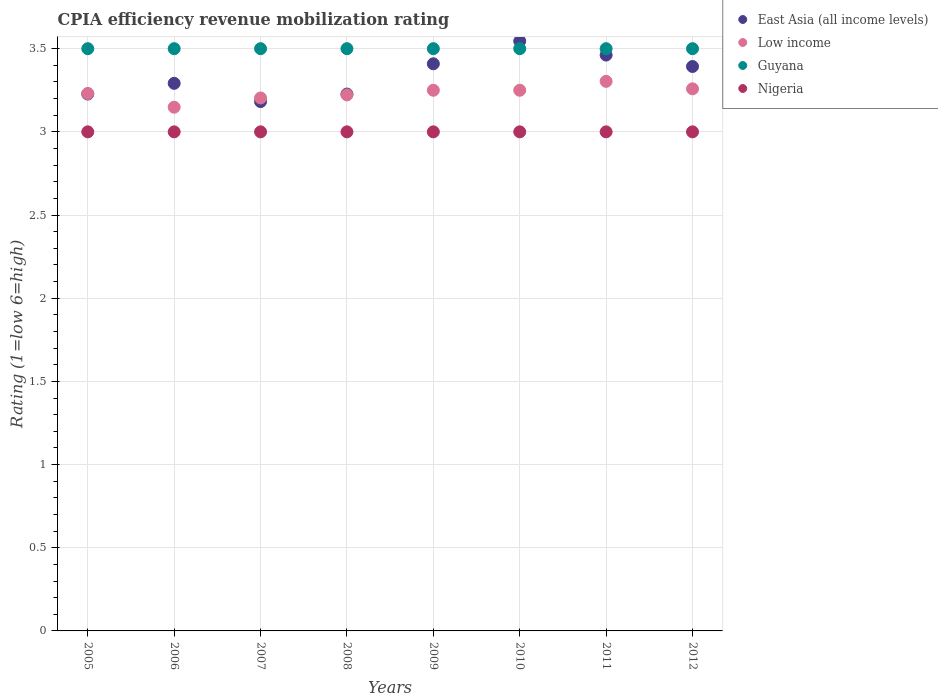Is the number of dotlines equal to the number of legend labels?
Ensure brevity in your answer.  Yes. What is the CPIA rating in East Asia (all income levels) in 2008?
Your answer should be very brief. 3.23. Across all years, what is the minimum CPIA rating in Nigeria?
Provide a short and direct response. 3. In which year was the CPIA rating in Nigeria maximum?
Offer a terse response. 2005. In which year was the CPIA rating in Low income minimum?
Provide a succinct answer. 2006. What is the total CPIA rating in Low income in the graph?
Provide a short and direct response. 25.87. In how many years, is the CPIA rating in Nigeria greater than 1.9?
Offer a terse response. 8. What is the ratio of the CPIA rating in East Asia (all income levels) in 2006 to that in 2007?
Offer a terse response. 1.03. What is the difference between the highest and the second highest CPIA rating in Guyana?
Ensure brevity in your answer.  0. What is the difference between the highest and the lowest CPIA rating in Nigeria?
Keep it short and to the point. 0. Is the sum of the CPIA rating in Guyana in 2008 and 2012 greater than the maximum CPIA rating in Low income across all years?
Make the answer very short. Yes. Does the CPIA rating in Low income monotonically increase over the years?
Your answer should be compact. No. What is the difference between two consecutive major ticks on the Y-axis?
Offer a terse response. 0.5. Where does the legend appear in the graph?
Keep it short and to the point. Top right. How are the legend labels stacked?
Your answer should be compact. Vertical. What is the title of the graph?
Your answer should be compact. CPIA efficiency revenue mobilization rating. What is the label or title of the X-axis?
Provide a succinct answer. Years. What is the Rating (1=low 6=high) of East Asia (all income levels) in 2005?
Your answer should be compact. 3.23. What is the Rating (1=low 6=high) in Low income in 2005?
Your answer should be very brief. 3.23. What is the Rating (1=low 6=high) in Guyana in 2005?
Offer a very short reply. 3.5. What is the Rating (1=low 6=high) of Nigeria in 2005?
Offer a very short reply. 3. What is the Rating (1=low 6=high) in East Asia (all income levels) in 2006?
Provide a short and direct response. 3.29. What is the Rating (1=low 6=high) in Low income in 2006?
Provide a succinct answer. 3.15. What is the Rating (1=low 6=high) in Nigeria in 2006?
Provide a succinct answer. 3. What is the Rating (1=low 6=high) in East Asia (all income levels) in 2007?
Provide a succinct answer. 3.18. What is the Rating (1=low 6=high) of Low income in 2007?
Ensure brevity in your answer.  3.2. What is the Rating (1=low 6=high) of Nigeria in 2007?
Provide a short and direct response. 3. What is the Rating (1=low 6=high) in East Asia (all income levels) in 2008?
Your answer should be compact. 3.23. What is the Rating (1=low 6=high) in Low income in 2008?
Your response must be concise. 3.22. What is the Rating (1=low 6=high) of Guyana in 2008?
Give a very brief answer. 3.5. What is the Rating (1=low 6=high) of East Asia (all income levels) in 2009?
Make the answer very short. 3.41. What is the Rating (1=low 6=high) of Guyana in 2009?
Your answer should be very brief. 3.5. What is the Rating (1=low 6=high) of East Asia (all income levels) in 2010?
Keep it short and to the point. 3.55. What is the Rating (1=low 6=high) in Low income in 2010?
Provide a short and direct response. 3.25. What is the Rating (1=low 6=high) in Guyana in 2010?
Your answer should be very brief. 3.5. What is the Rating (1=low 6=high) of Nigeria in 2010?
Make the answer very short. 3. What is the Rating (1=low 6=high) of East Asia (all income levels) in 2011?
Your answer should be compact. 3.46. What is the Rating (1=low 6=high) of Low income in 2011?
Offer a very short reply. 3.3. What is the Rating (1=low 6=high) in East Asia (all income levels) in 2012?
Your answer should be compact. 3.39. What is the Rating (1=low 6=high) of Low income in 2012?
Your answer should be compact. 3.26. Across all years, what is the maximum Rating (1=low 6=high) of East Asia (all income levels)?
Offer a very short reply. 3.55. Across all years, what is the maximum Rating (1=low 6=high) of Low income?
Your response must be concise. 3.3. Across all years, what is the maximum Rating (1=low 6=high) in Guyana?
Offer a terse response. 3.5. Across all years, what is the minimum Rating (1=low 6=high) in East Asia (all income levels)?
Offer a very short reply. 3.18. Across all years, what is the minimum Rating (1=low 6=high) of Low income?
Your answer should be very brief. 3.15. Across all years, what is the minimum Rating (1=low 6=high) of Guyana?
Provide a short and direct response. 3.5. Across all years, what is the minimum Rating (1=low 6=high) of Nigeria?
Provide a succinct answer. 3. What is the total Rating (1=low 6=high) in East Asia (all income levels) in the graph?
Ensure brevity in your answer.  26.74. What is the total Rating (1=low 6=high) of Low income in the graph?
Your answer should be very brief. 25.87. What is the total Rating (1=low 6=high) in Guyana in the graph?
Provide a succinct answer. 28. What is the difference between the Rating (1=low 6=high) in East Asia (all income levels) in 2005 and that in 2006?
Offer a terse response. -0.06. What is the difference between the Rating (1=low 6=high) in Low income in 2005 and that in 2006?
Provide a short and direct response. 0.08. What is the difference between the Rating (1=low 6=high) in Guyana in 2005 and that in 2006?
Provide a short and direct response. 0. What is the difference between the Rating (1=low 6=high) of East Asia (all income levels) in 2005 and that in 2007?
Offer a terse response. 0.05. What is the difference between the Rating (1=low 6=high) in Low income in 2005 and that in 2007?
Your answer should be compact. 0.03. What is the difference between the Rating (1=low 6=high) of Guyana in 2005 and that in 2007?
Make the answer very short. 0. What is the difference between the Rating (1=low 6=high) of East Asia (all income levels) in 2005 and that in 2008?
Offer a very short reply. 0. What is the difference between the Rating (1=low 6=high) of Low income in 2005 and that in 2008?
Offer a terse response. 0.01. What is the difference between the Rating (1=low 6=high) in Nigeria in 2005 and that in 2008?
Provide a short and direct response. 0. What is the difference between the Rating (1=low 6=high) in East Asia (all income levels) in 2005 and that in 2009?
Your answer should be very brief. -0.18. What is the difference between the Rating (1=low 6=high) of Low income in 2005 and that in 2009?
Ensure brevity in your answer.  -0.02. What is the difference between the Rating (1=low 6=high) of Guyana in 2005 and that in 2009?
Keep it short and to the point. 0. What is the difference between the Rating (1=low 6=high) in Nigeria in 2005 and that in 2009?
Make the answer very short. 0. What is the difference between the Rating (1=low 6=high) in East Asia (all income levels) in 2005 and that in 2010?
Your answer should be compact. -0.32. What is the difference between the Rating (1=low 6=high) in Low income in 2005 and that in 2010?
Your response must be concise. -0.02. What is the difference between the Rating (1=low 6=high) in East Asia (all income levels) in 2005 and that in 2011?
Offer a terse response. -0.23. What is the difference between the Rating (1=low 6=high) in Low income in 2005 and that in 2011?
Your response must be concise. -0.07. What is the difference between the Rating (1=low 6=high) in East Asia (all income levels) in 2005 and that in 2012?
Your response must be concise. -0.17. What is the difference between the Rating (1=low 6=high) in Low income in 2005 and that in 2012?
Your response must be concise. -0.03. What is the difference between the Rating (1=low 6=high) of Guyana in 2005 and that in 2012?
Make the answer very short. 0. What is the difference between the Rating (1=low 6=high) of East Asia (all income levels) in 2006 and that in 2007?
Provide a succinct answer. 0.11. What is the difference between the Rating (1=low 6=high) of Low income in 2006 and that in 2007?
Your response must be concise. -0.06. What is the difference between the Rating (1=low 6=high) of East Asia (all income levels) in 2006 and that in 2008?
Make the answer very short. 0.06. What is the difference between the Rating (1=low 6=high) in Low income in 2006 and that in 2008?
Your answer should be compact. -0.07. What is the difference between the Rating (1=low 6=high) of Guyana in 2006 and that in 2008?
Provide a short and direct response. 0. What is the difference between the Rating (1=low 6=high) in Nigeria in 2006 and that in 2008?
Provide a short and direct response. 0. What is the difference between the Rating (1=low 6=high) of East Asia (all income levels) in 2006 and that in 2009?
Provide a short and direct response. -0.12. What is the difference between the Rating (1=low 6=high) of Low income in 2006 and that in 2009?
Offer a very short reply. -0.1. What is the difference between the Rating (1=low 6=high) in East Asia (all income levels) in 2006 and that in 2010?
Your answer should be compact. -0.25. What is the difference between the Rating (1=low 6=high) of Low income in 2006 and that in 2010?
Your answer should be compact. -0.1. What is the difference between the Rating (1=low 6=high) in Guyana in 2006 and that in 2010?
Offer a very short reply. 0. What is the difference between the Rating (1=low 6=high) in East Asia (all income levels) in 2006 and that in 2011?
Ensure brevity in your answer.  -0.17. What is the difference between the Rating (1=low 6=high) in Low income in 2006 and that in 2011?
Provide a short and direct response. -0.16. What is the difference between the Rating (1=low 6=high) in Guyana in 2006 and that in 2011?
Make the answer very short. 0. What is the difference between the Rating (1=low 6=high) of East Asia (all income levels) in 2006 and that in 2012?
Your answer should be very brief. -0.1. What is the difference between the Rating (1=low 6=high) in Low income in 2006 and that in 2012?
Offer a terse response. -0.11. What is the difference between the Rating (1=low 6=high) in Nigeria in 2006 and that in 2012?
Provide a succinct answer. 0. What is the difference between the Rating (1=low 6=high) in East Asia (all income levels) in 2007 and that in 2008?
Ensure brevity in your answer.  -0.05. What is the difference between the Rating (1=low 6=high) of Low income in 2007 and that in 2008?
Your response must be concise. -0.02. What is the difference between the Rating (1=low 6=high) in East Asia (all income levels) in 2007 and that in 2009?
Make the answer very short. -0.23. What is the difference between the Rating (1=low 6=high) of Low income in 2007 and that in 2009?
Ensure brevity in your answer.  -0.05. What is the difference between the Rating (1=low 6=high) in Guyana in 2007 and that in 2009?
Your answer should be very brief. 0. What is the difference between the Rating (1=low 6=high) of Nigeria in 2007 and that in 2009?
Give a very brief answer. 0. What is the difference between the Rating (1=low 6=high) of East Asia (all income levels) in 2007 and that in 2010?
Keep it short and to the point. -0.36. What is the difference between the Rating (1=low 6=high) in Low income in 2007 and that in 2010?
Keep it short and to the point. -0.05. What is the difference between the Rating (1=low 6=high) in Nigeria in 2007 and that in 2010?
Provide a short and direct response. 0. What is the difference between the Rating (1=low 6=high) of East Asia (all income levels) in 2007 and that in 2011?
Your answer should be compact. -0.28. What is the difference between the Rating (1=low 6=high) of Low income in 2007 and that in 2011?
Offer a terse response. -0.1. What is the difference between the Rating (1=low 6=high) in Guyana in 2007 and that in 2011?
Keep it short and to the point. 0. What is the difference between the Rating (1=low 6=high) of East Asia (all income levels) in 2007 and that in 2012?
Keep it short and to the point. -0.21. What is the difference between the Rating (1=low 6=high) in Low income in 2007 and that in 2012?
Offer a very short reply. -0.05. What is the difference between the Rating (1=low 6=high) of Guyana in 2007 and that in 2012?
Offer a very short reply. 0. What is the difference between the Rating (1=low 6=high) of Nigeria in 2007 and that in 2012?
Offer a terse response. 0. What is the difference between the Rating (1=low 6=high) of East Asia (all income levels) in 2008 and that in 2009?
Provide a succinct answer. -0.18. What is the difference between the Rating (1=low 6=high) of Low income in 2008 and that in 2009?
Your answer should be very brief. -0.03. What is the difference between the Rating (1=low 6=high) of Guyana in 2008 and that in 2009?
Keep it short and to the point. 0. What is the difference between the Rating (1=low 6=high) in East Asia (all income levels) in 2008 and that in 2010?
Give a very brief answer. -0.32. What is the difference between the Rating (1=low 6=high) of Low income in 2008 and that in 2010?
Keep it short and to the point. -0.03. What is the difference between the Rating (1=low 6=high) of Guyana in 2008 and that in 2010?
Offer a terse response. 0. What is the difference between the Rating (1=low 6=high) in Nigeria in 2008 and that in 2010?
Your response must be concise. 0. What is the difference between the Rating (1=low 6=high) of East Asia (all income levels) in 2008 and that in 2011?
Offer a terse response. -0.23. What is the difference between the Rating (1=low 6=high) of Low income in 2008 and that in 2011?
Your answer should be very brief. -0.08. What is the difference between the Rating (1=low 6=high) in East Asia (all income levels) in 2008 and that in 2012?
Ensure brevity in your answer.  -0.17. What is the difference between the Rating (1=low 6=high) of Low income in 2008 and that in 2012?
Offer a very short reply. -0.04. What is the difference between the Rating (1=low 6=high) of Nigeria in 2008 and that in 2012?
Make the answer very short. 0. What is the difference between the Rating (1=low 6=high) in East Asia (all income levels) in 2009 and that in 2010?
Keep it short and to the point. -0.14. What is the difference between the Rating (1=low 6=high) in Nigeria in 2009 and that in 2010?
Keep it short and to the point. 0. What is the difference between the Rating (1=low 6=high) of East Asia (all income levels) in 2009 and that in 2011?
Keep it short and to the point. -0.05. What is the difference between the Rating (1=low 6=high) of Low income in 2009 and that in 2011?
Keep it short and to the point. -0.05. What is the difference between the Rating (1=low 6=high) in Nigeria in 2009 and that in 2011?
Offer a very short reply. 0. What is the difference between the Rating (1=low 6=high) of East Asia (all income levels) in 2009 and that in 2012?
Your answer should be compact. 0.02. What is the difference between the Rating (1=low 6=high) in Low income in 2009 and that in 2012?
Make the answer very short. -0.01. What is the difference between the Rating (1=low 6=high) of Nigeria in 2009 and that in 2012?
Offer a terse response. 0. What is the difference between the Rating (1=low 6=high) in East Asia (all income levels) in 2010 and that in 2011?
Your answer should be very brief. 0.08. What is the difference between the Rating (1=low 6=high) of Low income in 2010 and that in 2011?
Make the answer very short. -0.05. What is the difference between the Rating (1=low 6=high) of Nigeria in 2010 and that in 2011?
Provide a succinct answer. 0. What is the difference between the Rating (1=low 6=high) in East Asia (all income levels) in 2010 and that in 2012?
Offer a very short reply. 0.15. What is the difference between the Rating (1=low 6=high) in Low income in 2010 and that in 2012?
Give a very brief answer. -0.01. What is the difference between the Rating (1=low 6=high) of Guyana in 2010 and that in 2012?
Offer a very short reply. 0. What is the difference between the Rating (1=low 6=high) of East Asia (all income levels) in 2011 and that in 2012?
Your answer should be very brief. 0.07. What is the difference between the Rating (1=low 6=high) in Low income in 2011 and that in 2012?
Provide a succinct answer. 0.04. What is the difference between the Rating (1=low 6=high) in Guyana in 2011 and that in 2012?
Keep it short and to the point. 0. What is the difference between the Rating (1=low 6=high) of Nigeria in 2011 and that in 2012?
Provide a succinct answer. 0. What is the difference between the Rating (1=low 6=high) of East Asia (all income levels) in 2005 and the Rating (1=low 6=high) of Low income in 2006?
Provide a short and direct response. 0.08. What is the difference between the Rating (1=low 6=high) in East Asia (all income levels) in 2005 and the Rating (1=low 6=high) in Guyana in 2006?
Offer a terse response. -0.27. What is the difference between the Rating (1=low 6=high) in East Asia (all income levels) in 2005 and the Rating (1=low 6=high) in Nigeria in 2006?
Offer a very short reply. 0.23. What is the difference between the Rating (1=low 6=high) of Low income in 2005 and the Rating (1=low 6=high) of Guyana in 2006?
Ensure brevity in your answer.  -0.27. What is the difference between the Rating (1=low 6=high) of Low income in 2005 and the Rating (1=low 6=high) of Nigeria in 2006?
Your answer should be very brief. 0.23. What is the difference between the Rating (1=low 6=high) in Guyana in 2005 and the Rating (1=low 6=high) in Nigeria in 2006?
Keep it short and to the point. 0.5. What is the difference between the Rating (1=low 6=high) of East Asia (all income levels) in 2005 and the Rating (1=low 6=high) of Low income in 2007?
Your answer should be very brief. 0.02. What is the difference between the Rating (1=low 6=high) of East Asia (all income levels) in 2005 and the Rating (1=low 6=high) of Guyana in 2007?
Keep it short and to the point. -0.27. What is the difference between the Rating (1=low 6=high) in East Asia (all income levels) in 2005 and the Rating (1=low 6=high) in Nigeria in 2007?
Provide a short and direct response. 0.23. What is the difference between the Rating (1=low 6=high) in Low income in 2005 and the Rating (1=low 6=high) in Guyana in 2007?
Offer a terse response. -0.27. What is the difference between the Rating (1=low 6=high) of Low income in 2005 and the Rating (1=low 6=high) of Nigeria in 2007?
Offer a terse response. 0.23. What is the difference between the Rating (1=low 6=high) in Guyana in 2005 and the Rating (1=low 6=high) in Nigeria in 2007?
Offer a very short reply. 0.5. What is the difference between the Rating (1=low 6=high) of East Asia (all income levels) in 2005 and the Rating (1=low 6=high) of Low income in 2008?
Make the answer very short. 0.01. What is the difference between the Rating (1=low 6=high) in East Asia (all income levels) in 2005 and the Rating (1=low 6=high) in Guyana in 2008?
Your response must be concise. -0.27. What is the difference between the Rating (1=low 6=high) of East Asia (all income levels) in 2005 and the Rating (1=low 6=high) of Nigeria in 2008?
Your response must be concise. 0.23. What is the difference between the Rating (1=low 6=high) in Low income in 2005 and the Rating (1=low 6=high) in Guyana in 2008?
Provide a succinct answer. -0.27. What is the difference between the Rating (1=low 6=high) of Low income in 2005 and the Rating (1=low 6=high) of Nigeria in 2008?
Your answer should be very brief. 0.23. What is the difference between the Rating (1=low 6=high) of East Asia (all income levels) in 2005 and the Rating (1=low 6=high) of Low income in 2009?
Offer a very short reply. -0.02. What is the difference between the Rating (1=low 6=high) in East Asia (all income levels) in 2005 and the Rating (1=low 6=high) in Guyana in 2009?
Ensure brevity in your answer.  -0.27. What is the difference between the Rating (1=low 6=high) of East Asia (all income levels) in 2005 and the Rating (1=low 6=high) of Nigeria in 2009?
Your answer should be very brief. 0.23. What is the difference between the Rating (1=low 6=high) of Low income in 2005 and the Rating (1=low 6=high) of Guyana in 2009?
Offer a very short reply. -0.27. What is the difference between the Rating (1=low 6=high) of Low income in 2005 and the Rating (1=low 6=high) of Nigeria in 2009?
Keep it short and to the point. 0.23. What is the difference between the Rating (1=low 6=high) of East Asia (all income levels) in 2005 and the Rating (1=low 6=high) of Low income in 2010?
Offer a terse response. -0.02. What is the difference between the Rating (1=low 6=high) of East Asia (all income levels) in 2005 and the Rating (1=low 6=high) of Guyana in 2010?
Give a very brief answer. -0.27. What is the difference between the Rating (1=low 6=high) of East Asia (all income levels) in 2005 and the Rating (1=low 6=high) of Nigeria in 2010?
Provide a succinct answer. 0.23. What is the difference between the Rating (1=low 6=high) of Low income in 2005 and the Rating (1=low 6=high) of Guyana in 2010?
Keep it short and to the point. -0.27. What is the difference between the Rating (1=low 6=high) in Low income in 2005 and the Rating (1=low 6=high) in Nigeria in 2010?
Offer a terse response. 0.23. What is the difference between the Rating (1=low 6=high) of East Asia (all income levels) in 2005 and the Rating (1=low 6=high) of Low income in 2011?
Offer a very short reply. -0.08. What is the difference between the Rating (1=low 6=high) of East Asia (all income levels) in 2005 and the Rating (1=low 6=high) of Guyana in 2011?
Your answer should be very brief. -0.27. What is the difference between the Rating (1=low 6=high) of East Asia (all income levels) in 2005 and the Rating (1=low 6=high) of Nigeria in 2011?
Offer a terse response. 0.23. What is the difference between the Rating (1=low 6=high) of Low income in 2005 and the Rating (1=low 6=high) of Guyana in 2011?
Make the answer very short. -0.27. What is the difference between the Rating (1=low 6=high) in Low income in 2005 and the Rating (1=low 6=high) in Nigeria in 2011?
Make the answer very short. 0.23. What is the difference between the Rating (1=low 6=high) of Guyana in 2005 and the Rating (1=low 6=high) of Nigeria in 2011?
Offer a very short reply. 0.5. What is the difference between the Rating (1=low 6=high) in East Asia (all income levels) in 2005 and the Rating (1=low 6=high) in Low income in 2012?
Provide a short and direct response. -0.03. What is the difference between the Rating (1=low 6=high) of East Asia (all income levels) in 2005 and the Rating (1=low 6=high) of Guyana in 2012?
Make the answer very short. -0.27. What is the difference between the Rating (1=low 6=high) of East Asia (all income levels) in 2005 and the Rating (1=low 6=high) of Nigeria in 2012?
Ensure brevity in your answer.  0.23. What is the difference between the Rating (1=low 6=high) in Low income in 2005 and the Rating (1=low 6=high) in Guyana in 2012?
Ensure brevity in your answer.  -0.27. What is the difference between the Rating (1=low 6=high) in Low income in 2005 and the Rating (1=low 6=high) in Nigeria in 2012?
Provide a succinct answer. 0.23. What is the difference between the Rating (1=low 6=high) in Guyana in 2005 and the Rating (1=low 6=high) in Nigeria in 2012?
Provide a succinct answer. 0.5. What is the difference between the Rating (1=low 6=high) of East Asia (all income levels) in 2006 and the Rating (1=low 6=high) of Low income in 2007?
Provide a short and direct response. 0.09. What is the difference between the Rating (1=low 6=high) in East Asia (all income levels) in 2006 and the Rating (1=low 6=high) in Guyana in 2007?
Offer a very short reply. -0.21. What is the difference between the Rating (1=low 6=high) in East Asia (all income levels) in 2006 and the Rating (1=low 6=high) in Nigeria in 2007?
Offer a terse response. 0.29. What is the difference between the Rating (1=low 6=high) in Low income in 2006 and the Rating (1=low 6=high) in Guyana in 2007?
Keep it short and to the point. -0.35. What is the difference between the Rating (1=low 6=high) in Low income in 2006 and the Rating (1=low 6=high) in Nigeria in 2007?
Your response must be concise. 0.15. What is the difference between the Rating (1=low 6=high) in East Asia (all income levels) in 2006 and the Rating (1=low 6=high) in Low income in 2008?
Provide a succinct answer. 0.07. What is the difference between the Rating (1=low 6=high) in East Asia (all income levels) in 2006 and the Rating (1=low 6=high) in Guyana in 2008?
Keep it short and to the point. -0.21. What is the difference between the Rating (1=low 6=high) of East Asia (all income levels) in 2006 and the Rating (1=low 6=high) of Nigeria in 2008?
Make the answer very short. 0.29. What is the difference between the Rating (1=low 6=high) of Low income in 2006 and the Rating (1=low 6=high) of Guyana in 2008?
Make the answer very short. -0.35. What is the difference between the Rating (1=low 6=high) of Low income in 2006 and the Rating (1=low 6=high) of Nigeria in 2008?
Your answer should be compact. 0.15. What is the difference between the Rating (1=low 6=high) of Guyana in 2006 and the Rating (1=low 6=high) of Nigeria in 2008?
Provide a short and direct response. 0.5. What is the difference between the Rating (1=low 6=high) of East Asia (all income levels) in 2006 and the Rating (1=low 6=high) of Low income in 2009?
Your response must be concise. 0.04. What is the difference between the Rating (1=low 6=high) of East Asia (all income levels) in 2006 and the Rating (1=low 6=high) of Guyana in 2009?
Ensure brevity in your answer.  -0.21. What is the difference between the Rating (1=low 6=high) in East Asia (all income levels) in 2006 and the Rating (1=low 6=high) in Nigeria in 2009?
Your answer should be very brief. 0.29. What is the difference between the Rating (1=low 6=high) in Low income in 2006 and the Rating (1=low 6=high) in Guyana in 2009?
Ensure brevity in your answer.  -0.35. What is the difference between the Rating (1=low 6=high) in Low income in 2006 and the Rating (1=low 6=high) in Nigeria in 2009?
Your answer should be compact. 0.15. What is the difference between the Rating (1=low 6=high) of East Asia (all income levels) in 2006 and the Rating (1=low 6=high) of Low income in 2010?
Offer a terse response. 0.04. What is the difference between the Rating (1=low 6=high) of East Asia (all income levels) in 2006 and the Rating (1=low 6=high) of Guyana in 2010?
Your answer should be compact. -0.21. What is the difference between the Rating (1=low 6=high) of East Asia (all income levels) in 2006 and the Rating (1=low 6=high) of Nigeria in 2010?
Your response must be concise. 0.29. What is the difference between the Rating (1=low 6=high) in Low income in 2006 and the Rating (1=low 6=high) in Guyana in 2010?
Your response must be concise. -0.35. What is the difference between the Rating (1=low 6=high) in Low income in 2006 and the Rating (1=low 6=high) in Nigeria in 2010?
Offer a terse response. 0.15. What is the difference between the Rating (1=low 6=high) of Guyana in 2006 and the Rating (1=low 6=high) of Nigeria in 2010?
Offer a very short reply. 0.5. What is the difference between the Rating (1=low 6=high) in East Asia (all income levels) in 2006 and the Rating (1=low 6=high) in Low income in 2011?
Keep it short and to the point. -0.01. What is the difference between the Rating (1=low 6=high) in East Asia (all income levels) in 2006 and the Rating (1=low 6=high) in Guyana in 2011?
Offer a very short reply. -0.21. What is the difference between the Rating (1=low 6=high) of East Asia (all income levels) in 2006 and the Rating (1=low 6=high) of Nigeria in 2011?
Your answer should be very brief. 0.29. What is the difference between the Rating (1=low 6=high) of Low income in 2006 and the Rating (1=low 6=high) of Guyana in 2011?
Give a very brief answer. -0.35. What is the difference between the Rating (1=low 6=high) in Low income in 2006 and the Rating (1=low 6=high) in Nigeria in 2011?
Offer a terse response. 0.15. What is the difference between the Rating (1=low 6=high) in East Asia (all income levels) in 2006 and the Rating (1=low 6=high) in Low income in 2012?
Offer a terse response. 0.03. What is the difference between the Rating (1=low 6=high) in East Asia (all income levels) in 2006 and the Rating (1=low 6=high) in Guyana in 2012?
Your response must be concise. -0.21. What is the difference between the Rating (1=low 6=high) of East Asia (all income levels) in 2006 and the Rating (1=low 6=high) of Nigeria in 2012?
Provide a succinct answer. 0.29. What is the difference between the Rating (1=low 6=high) in Low income in 2006 and the Rating (1=low 6=high) in Guyana in 2012?
Your response must be concise. -0.35. What is the difference between the Rating (1=low 6=high) in Low income in 2006 and the Rating (1=low 6=high) in Nigeria in 2012?
Ensure brevity in your answer.  0.15. What is the difference between the Rating (1=low 6=high) in East Asia (all income levels) in 2007 and the Rating (1=low 6=high) in Low income in 2008?
Offer a very short reply. -0.04. What is the difference between the Rating (1=low 6=high) of East Asia (all income levels) in 2007 and the Rating (1=low 6=high) of Guyana in 2008?
Ensure brevity in your answer.  -0.32. What is the difference between the Rating (1=low 6=high) in East Asia (all income levels) in 2007 and the Rating (1=low 6=high) in Nigeria in 2008?
Make the answer very short. 0.18. What is the difference between the Rating (1=low 6=high) in Low income in 2007 and the Rating (1=low 6=high) in Guyana in 2008?
Offer a terse response. -0.3. What is the difference between the Rating (1=low 6=high) in Low income in 2007 and the Rating (1=low 6=high) in Nigeria in 2008?
Provide a short and direct response. 0.2. What is the difference between the Rating (1=low 6=high) of Guyana in 2007 and the Rating (1=low 6=high) of Nigeria in 2008?
Offer a very short reply. 0.5. What is the difference between the Rating (1=low 6=high) in East Asia (all income levels) in 2007 and the Rating (1=low 6=high) in Low income in 2009?
Ensure brevity in your answer.  -0.07. What is the difference between the Rating (1=low 6=high) in East Asia (all income levels) in 2007 and the Rating (1=low 6=high) in Guyana in 2009?
Offer a terse response. -0.32. What is the difference between the Rating (1=low 6=high) of East Asia (all income levels) in 2007 and the Rating (1=low 6=high) of Nigeria in 2009?
Provide a short and direct response. 0.18. What is the difference between the Rating (1=low 6=high) in Low income in 2007 and the Rating (1=low 6=high) in Guyana in 2009?
Keep it short and to the point. -0.3. What is the difference between the Rating (1=low 6=high) in Low income in 2007 and the Rating (1=low 6=high) in Nigeria in 2009?
Your response must be concise. 0.2. What is the difference between the Rating (1=low 6=high) of Guyana in 2007 and the Rating (1=low 6=high) of Nigeria in 2009?
Offer a very short reply. 0.5. What is the difference between the Rating (1=low 6=high) in East Asia (all income levels) in 2007 and the Rating (1=low 6=high) in Low income in 2010?
Make the answer very short. -0.07. What is the difference between the Rating (1=low 6=high) of East Asia (all income levels) in 2007 and the Rating (1=low 6=high) of Guyana in 2010?
Keep it short and to the point. -0.32. What is the difference between the Rating (1=low 6=high) in East Asia (all income levels) in 2007 and the Rating (1=low 6=high) in Nigeria in 2010?
Offer a very short reply. 0.18. What is the difference between the Rating (1=low 6=high) in Low income in 2007 and the Rating (1=low 6=high) in Guyana in 2010?
Your answer should be compact. -0.3. What is the difference between the Rating (1=low 6=high) in Low income in 2007 and the Rating (1=low 6=high) in Nigeria in 2010?
Keep it short and to the point. 0.2. What is the difference between the Rating (1=low 6=high) in Guyana in 2007 and the Rating (1=low 6=high) in Nigeria in 2010?
Ensure brevity in your answer.  0.5. What is the difference between the Rating (1=low 6=high) of East Asia (all income levels) in 2007 and the Rating (1=low 6=high) of Low income in 2011?
Give a very brief answer. -0.12. What is the difference between the Rating (1=low 6=high) in East Asia (all income levels) in 2007 and the Rating (1=low 6=high) in Guyana in 2011?
Give a very brief answer. -0.32. What is the difference between the Rating (1=low 6=high) in East Asia (all income levels) in 2007 and the Rating (1=low 6=high) in Nigeria in 2011?
Make the answer very short. 0.18. What is the difference between the Rating (1=low 6=high) in Low income in 2007 and the Rating (1=low 6=high) in Guyana in 2011?
Your response must be concise. -0.3. What is the difference between the Rating (1=low 6=high) in Low income in 2007 and the Rating (1=low 6=high) in Nigeria in 2011?
Ensure brevity in your answer.  0.2. What is the difference between the Rating (1=low 6=high) in Guyana in 2007 and the Rating (1=low 6=high) in Nigeria in 2011?
Offer a terse response. 0.5. What is the difference between the Rating (1=low 6=high) in East Asia (all income levels) in 2007 and the Rating (1=low 6=high) in Low income in 2012?
Your answer should be very brief. -0.08. What is the difference between the Rating (1=low 6=high) in East Asia (all income levels) in 2007 and the Rating (1=low 6=high) in Guyana in 2012?
Your response must be concise. -0.32. What is the difference between the Rating (1=low 6=high) of East Asia (all income levels) in 2007 and the Rating (1=low 6=high) of Nigeria in 2012?
Offer a very short reply. 0.18. What is the difference between the Rating (1=low 6=high) of Low income in 2007 and the Rating (1=low 6=high) of Guyana in 2012?
Your response must be concise. -0.3. What is the difference between the Rating (1=low 6=high) in Low income in 2007 and the Rating (1=low 6=high) in Nigeria in 2012?
Keep it short and to the point. 0.2. What is the difference between the Rating (1=low 6=high) of Guyana in 2007 and the Rating (1=low 6=high) of Nigeria in 2012?
Give a very brief answer. 0.5. What is the difference between the Rating (1=low 6=high) in East Asia (all income levels) in 2008 and the Rating (1=low 6=high) in Low income in 2009?
Keep it short and to the point. -0.02. What is the difference between the Rating (1=low 6=high) in East Asia (all income levels) in 2008 and the Rating (1=low 6=high) in Guyana in 2009?
Provide a succinct answer. -0.27. What is the difference between the Rating (1=low 6=high) in East Asia (all income levels) in 2008 and the Rating (1=low 6=high) in Nigeria in 2009?
Provide a short and direct response. 0.23. What is the difference between the Rating (1=low 6=high) of Low income in 2008 and the Rating (1=low 6=high) of Guyana in 2009?
Your answer should be compact. -0.28. What is the difference between the Rating (1=low 6=high) in Low income in 2008 and the Rating (1=low 6=high) in Nigeria in 2009?
Offer a very short reply. 0.22. What is the difference between the Rating (1=low 6=high) in Guyana in 2008 and the Rating (1=low 6=high) in Nigeria in 2009?
Provide a short and direct response. 0.5. What is the difference between the Rating (1=low 6=high) in East Asia (all income levels) in 2008 and the Rating (1=low 6=high) in Low income in 2010?
Give a very brief answer. -0.02. What is the difference between the Rating (1=low 6=high) in East Asia (all income levels) in 2008 and the Rating (1=low 6=high) in Guyana in 2010?
Provide a short and direct response. -0.27. What is the difference between the Rating (1=low 6=high) of East Asia (all income levels) in 2008 and the Rating (1=low 6=high) of Nigeria in 2010?
Provide a succinct answer. 0.23. What is the difference between the Rating (1=low 6=high) of Low income in 2008 and the Rating (1=low 6=high) of Guyana in 2010?
Provide a succinct answer. -0.28. What is the difference between the Rating (1=low 6=high) of Low income in 2008 and the Rating (1=low 6=high) of Nigeria in 2010?
Offer a terse response. 0.22. What is the difference between the Rating (1=low 6=high) in East Asia (all income levels) in 2008 and the Rating (1=low 6=high) in Low income in 2011?
Provide a short and direct response. -0.08. What is the difference between the Rating (1=low 6=high) of East Asia (all income levels) in 2008 and the Rating (1=low 6=high) of Guyana in 2011?
Give a very brief answer. -0.27. What is the difference between the Rating (1=low 6=high) of East Asia (all income levels) in 2008 and the Rating (1=low 6=high) of Nigeria in 2011?
Give a very brief answer. 0.23. What is the difference between the Rating (1=low 6=high) of Low income in 2008 and the Rating (1=low 6=high) of Guyana in 2011?
Your response must be concise. -0.28. What is the difference between the Rating (1=low 6=high) in Low income in 2008 and the Rating (1=low 6=high) in Nigeria in 2011?
Provide a succinct answer. 0.22. What is the difference between the Rating (1=low 6=high) of East Asia (all income levels) in 2008 and the Rating (1=low 6=high) of Low income in 2012?
Your answer should be compact. -0.03. What is the difference between the Rating (1=low 6=high) of East Asia (all income levels) in 2008 and the Rating (1=low 6=high) of Guyana in 2012?
Offer a very short reply. -0.27. What is the difference between the Rating (1=low 6=high) in East Asia (all income levels) in 2008 and the Rating (1=low 6=high) in Nigeria in 2012?
Keep it short and to the point. 0.23. What is the difference between the Rating (1=low 6=high) of Low income in 2008 and the Rating (1=low 6=high) of Guyana in 2012?
Offer a terse response. -0.28. What is the difference between the Rating (1=low 6=high) in Low income in 2008 and the Rating (1=low 6=high) in Nigeria in 2012?
Your response must be concise. 0.22. What is the difference between the Rating (1=low 6=high) in East Asia (all income levels) in 2009 and the Rating (1=low 6=high) in Low income in 2010?
Offer a terse response. 0.16. What is the difference between the Rating (1=low 6=high) of East Asia (all income levels) in 2009 and the Rating (1=low 6=high) of Guyana in 2010?
Offer a terse response. -0.09. What is the difference between the Rating (1=low 6=high) of East Asia (all income levels) in 2009 and the Rating (1=low 6=high) of Nigeria in 2010?
Give a very brief answer. 0.41. What is the difference between the Rating (1=low 6=high) of Low income in 2009 and the Rating (1=low 6=high) of Guyana in 2010?
Provide a short and direct response. -0.25. What is the difference between the Rating (1=low 6=high) of Low income in 2009 and the Rating (1=low 6=high) of Nigeria in 2010?
Provide a succinct answer. 0.25. What is the difference between the Rating (1=low 6=high) in East Asia (all income levels) in 2009 and the Rating (1=low 6=high) in Low income in 2011?
Provide a short and direct response. 0.11. What is the difference between the Rating (1=low 6=high) of East Asia (all income levels) in 2009 and the Rating (1=low 6=high) of Guyana in 2011?
Offer a terse response. -0.09. What is the difference between the Rating (1=low 6=high) of East Asia (all income levels) in 2009 and the Rating (1=low 6=high) of Nigeria in 2011?
Provide a short and direct response. 0.41. What is the difference between the Rating (1=low 6=high) of Low income in 2009 and the Rating (1=low 6=high) of Nigeria in 2011?
Provide a succinct answer. 0.25. What is the difference between the Rating (1=low 6=high) in Guyana in 2009 and the Rating (1=low 6=high) in Nigeria in 2011?
Make the answer very short. 0.5. What is the difference between the Rating (1=low 6=high) in East Asia (all income levels) in 2009 and the Rating (1=low 6=high) in Low income in 2012?
Make the answer very short. 0.15. What is the difference between the Rating (1=low 6=high) in East Asia (all income levels) in 2009 and the Rating (1=low 6=high) in Guyana in 2012?
Offer a terse response. -0.09. What is the difference between the Rating (1=low 6=high) in East Asia (all income levels) in 2009 and the Rating (1=low 6=high) in Nigeria in 2012?
Make the answer very short. 0.41. What is the difference between the Rating (1=low 6=high) of Low income in 2009 and the Rating (1=low 6=high) of Guyana in 2012?
Make the answer very short. -0.25. What is the difference between the Rating (1=low 6=high) of Low income in 2009 and the Rating (1=low 6=high) of Nigeria in 2012?
Offer a very short reply. 0.25. What is the difference between the Rating (1=low 6=high) of East Asia (all income levels) in 2010 and the Rating (1=low 6=high) of Low income in 2011?
Offer a terse response. 0.24. What is the difference between the Rating (1=low 6=high) in East Asia (all income levels) in 2010 and the Rating (1=low 6=high) in Guyana in 2011?
Make the answer very short. 0.05. What is the difference between the Rating (1=low 6=high) of East Asia (all income levels) in 2010 and the Rating (1=low 6=high) of Nigeria in 2011?
Provide a short and direct response. 0.55. What is the difference between the Rating (1=low 6=high) of Low income in 2010 and the Rating (1=low 6=high) of Guyana in 2011?
Your response must be concise. -0.25. What is the difference between the Rating (1=low 6=high) in Guyana in 2010 and the Rating (1=low 6=high) in Nigeria in 2011?
Your response must be concise. 0.5. What is the difference between the Rating (1=low 6=high) of East Asia (all income levels) in 2010 and the Rating (1=low 6=high) of Low income in 2012?
Provide a short and direct response. 0.29. What is the difference between the Rating (1=low 6=high) in East Asia (all income levels) in 2010 and the Rating (1=low 6=high) in Guyana in 2012?
Your answer should be very brief. 0.05. What is the difference between the Rating (1=low 6=high) in East Asia (all income levels) in 2010 and the Rating (1=low 6=high) in Nigeria in 2012?
Offer a very short reply. 0.55. What is the difference between the Rating (1=low 6=high) in Guyana in 2010 and the Rating (1=low 6=high) in Nigeria in 2012?
Ensure brevity in your answer.  0.5. What is the difference between the Rating (1=low 6=high) of East Asia (all income levels) in 2011 and the Rating (1=low 6=high) of Low income in 2012?
Offer a very short reply. 0.2. What is the difference between the Rating (1=low 6=high) in East Asia (all income levels) in 2011 and the Rating (1=low 6=high) in Guyana in 2012?
Make the answer very short. -0.04. What is the difference between the Rating (1=low 6=high) of East Asia (all income levels) in 2011 and the Rating (1=low 6=high) of Nigeria in 2012?
Ensure brevity in your answer.  0.46. What is the difference between the Rating (1=low 6=high) of Low income in 2011 and the Rating (1=low 6=high) of Guyana in 2012?
Keep it short and to the point. -0.2. What is the difference between the Rating (1=low 6=high) of Low income in 2011 and the Rating (1=low 6=high) of Nigeria in 2012?
Your answer should be very brief. 0.3. What is the average Rating (1=low 6=high) of East Asia (all income levels) per year?
Make the answer very short. 3.34. What is the average Rating (1=low 6=high) of Low income per year?
Your answer should be compact. 3.23. What is the average Rating (1=low 6=high) in Guyana per year?
Ensure brevity in your answer.  3.5. What is the average Rating (1=low 6=high) of Nigeria per year?
Keep it short and to the point. 3. In the year 2005, what is the difference between the Rating (1=low 6=high) in East Asia (all income levels) and Rating (1=low 6=high) in Low income?
Ensure brevity in your answer.  -0. In the year 2005, what is the difference between the Rating (1=low 6=high) of East Asia (all income levels) and Rating (1=low 6=high) of Guyana?
Your answer should be very brief. -0.27. In the year 2005, what is the difference between the Rating (1=low 6=high) in East Asia (all income levels) and Rating (1=low 6=high) in Nigeria?
Keep it short and to the point. 0.23. In the year 2005, what is the difference between the Rating (1=low 6=high) in Low income and Rating (1=low 6=high) in Guyana?
Provide a short and direct response. -0.27. In the year 2005, what is the difference between the Rating (1=low 6=high) in Low income and Rating (1=low 6=high) in Nigeria?
Your response must be concise. 0.23. In the year 2006, what is the difference between the Rating (1=low 6=high) in East Asia (all income levels) and Rating (1=low 6=high) in Low income?
Ensure brevity in your answer.  0.14. In the year 2006, what is the difference between the Rating (1=low 6=high) of East Asia (all income levels) and Rating (1=low 6=high) of Guyana?
Make the answer very short. -0.21. In the year 2006, what is the difference between the Rating (1=low 6=high) of East Asia (all income levels) and Rating (1=low 6=high) of Nigeria?
Provide a succinct answer. 0.29. In the year 2006, what is the difference between the Rating (1=low 6=high) in Low income and Rating (1=low 6=high) in Guyana?
Make the answer very short. -0.35. In the year 2006, what is the difference between the Rating (1=low 6=high) in Low income and Rating (1=low 6=high) in Nigeria?
Keep it short and to the point. 0.15. In the year 2006, what is the difference between the Rating (1=low 6=high) of Guyana and Rating (1=low 6=high) of Nigeria?
Ensure brevity in your answer.  0.5. In the year 2007, what is the difference between the Rating (1=low 6=high) of East Asia (all income levels) and Rating (1=low 6=high) of Low income?
Provide a short and direct response. -0.02. In the year 2007, what is the difference between the Rating (1=low 6=high) of East Asia (all income levels) and Rating (1=low 6=high) of Guyana?
Your answer should be compact. -0.32. In the year 2007, what is the difference between the Rating (1=low 6=high) in East Asia (all income levels) and Rating (1=low 6=high) in Nigeria?
Ensure brevity in your answer.  0.18. In the year 2007, what is the difference between the Rating (1=low 6=high) of Low income and Rating (1=low 6=high) of Guyana?
Keep it short and to the point. -0.3. In the year 2007, what is the difference between the Rating (1=low 6=high) of Low income and Rating (1=low 6=high) of Nigeria?
Provide a short and direct response. 0.2. In the year 2007, what is the difference between the Rating (1=low 6=high) in Guyana and Rating (1=low 6=high) in Nigeria?
Provide a short and direct response. 0.5. In the year 2008, what is the difference between the Rating (1=low 6=high) in East Asia (all income levels) and Rating (1=low 6=high) in Low income?
Your answer should be compact. 0.01. In the year 2008, what is the difference between the Rating (1=low 6=high) of East Asia (all income levels) and Rating (1=low 6=high) of Guyana?
Offer a very short reply. -0.27. In the year 2008, what is the difference between the Rating (1=low 6=high) of East Asia (all income levels) and Rating (1=low 6=high) of Nigeria?
Ensure brevity in your answer.  0.23. In the year 2008, what is the difference between the Rating (1=low 6=high) of Low income and Rating (1=low 6=high) of Guyana?
Your response must be concise. -0.28. In the year 2008, what is the difference between the Rating (1=low 6=high) of Low income and Rating (1=low 6=high) of Nigeria?
Offer a very short reply. 0.22. In the year 2008, what is the difference between the Rating (1=low 6=high) in Guyana and Rating (1=low 6=high) in Nigeria?
Your answer should be compact. 0.5. In the year 2009, what is the difference between the Rating (1=low 6=high) of East Asia (all income levels) and Rating (1=low 6=high) of Low income?
Provide a succinct answer. 0.16. In the year 2009, what is the difference between the Rating (1=low 6=high) in East Asia (all income levels) and Rating (1=low 6=high) in Guyana?
Your answer should be very brief. -0.09. In the year 2009, what is the difference between the Rating (1=low 6=high) of East Asia (all income levels) and Rating (1=low 6=high) of Nigeria?
Your answer should be compact. 0.41. In the year 2009, what is the difference between the Rating (1=low 6=high) in Guyana and Rating (1=low 6=high) in Nigeria?
Your answer should be very brief. 0.5. In the year 2010, what is the difference between the Rating (1=low 6=high) in East Asia (all income levels) and Rating (1=low 6=high) in Low income?
Make the answer very short. 0.3. In the year 2010, what is the difference between the Rating (1=low 6=high) in East Asia (all income levels) and Rating (1=low 6=high) in Guyana?
Ensure brevity in your answer.  0.05. In the year 2010, what is the difference between the Rating (1=low 6=high) in East Asia (all income levels) and Rating (1=low 6=high) in Nigeria?
Offer a very short reply. 0.55. In the year 2011, what is the difference between the Rating (1=low 6=high) of East Asia (all income levels) and Rating (1=low 6=high) of Low income?
Offer a very short reply. 0.16. In the year 2011, what is the difference between the Rating (1=low 6=high) of East Asia (all income levels) and Rating (1=low 6=high) of Guyana?
Offer a terse response. -0.04. In the year 2011, what is the difference between the Rating (1=low 6=high) in East Asia (all income levels) and Rating (1=low 6=high) in Nigeria?
Provide a succinct answer. 0.46. In the year 2011, what is the difference between the Rating (1=low 6=high) of Low income and Rating (1=low 6=high) of Guyana?
Provide a succinct answer. -0.2. In the year 2011, what is the difference between the Rating (1=low 6=high) of Low income and Rating (1=low 6=high) of Nigeria?
Provide a short and direct response. 0.3. In the year 2011, what is the difference between the Rating (1=low 6=high) in Guyana and Rating (1=low 6=high) in Nigeria?
Your answer should be compact. 0.5. In the year 2012, what is the difference between the Rating (1=low 6=high) in East Asia (all income levels) and Rating (1=low 6=high) in Low income?
Ensure brevity in your answer.  0.13. In the year 2012, what is the difference between the Rating (1=low 6=high) of East Asia (all income levels) and Rating (1=low 6=high) of Guyana?
Make the answer very short. -0.11. In the year 2012, what is the difference between the Rating (1=low 6=high) of East Asia (all income levels) and Rating (1=low 6=high) of Nigeria?
Offer a very short reply. 0.39. In the year 2012, what is the difference between the Rating (1=low 6=high) of Low income and Rating (1=low 6=high) of Guyana?
Make the answer very short. -0.24. In the year 2012, what is the difference between the Rating (1=low 6=high) in Low income and Rating (1=low 6=high) in Nigeria?
Your answer should be compact. 0.26. What is the ratio of the Rating (1=low 6=high) of East Asia (all income levels) in 2005 to that in 2006?
Give a very brief answer. 0.98. What is the ratio of the Rating (1=low 6=high) in Low income in 2005 to that in 2006?
Make the answer very short. 1.03. What is the ratio of the Rating (1=low 6=high) in Guyana in 2005 to that in 2006?
Ensure brevity in your answer.  1. What is the ratio of the Rating (1=low 6=high) of Nigeria in 2005 to that in 2006?
Provide a succinct answer. 1. What is the ratio of the Rating (1=low 6=high) of East Asia (all income levels) in 2005 to that in 2007?
Offer a terse response. 1.01. What is the ratio of the Rating (1=low 6=high) of Low income in 2005 to that in 2007?
Offer a very short reply. 1.01. What is the ratio of the Rating (1=low 6=high) of Guyana in 2005 to that in 2007?
Ensure brevity in your answer.  1. What is the ratio of the Rating (1=low 6=high) of East Asia (all income levels) in 2005 to that in 2009?
Provide a short and direct response. 0.95. What is the ratio of the Rating (1=low 6=high) of Low income in 2005 to that in 2009?
Give a very brief answer. 0.99. What is the ratio of the Rating (1=low 6=high) in Guyana in 2005 to that in 2009?
Offer a terse response. 1. What is the ratio of the Rating (1=low 6=high) in Nigeria in 2005 to that in 2009?
Keep it short and to the point. 1. What is the ratio of the Rating (1=low 6=high) of East Asia (all income levels) in 2005 to that in 2010?
Offer a terse response. 0.91. What is the ratio of the Rating (1=low 6=high) of East Asia (all income levels) in 2005 to that in 2011?
Keep it short and to the point. 0.93. What is the ratio of the Rating (1=low 6=high) of Nigeria in 2005 to that in 2011?
Offer a very short reply. 1. What is the ratio of the Rating (1=low 6=high) of East Asia (all income levels) in 2005 to that in 2012?
Offer a very short reply. 0.95. What is the ratio of the Rating (1=low 6=high) of Guyana in 2005 to that in 2012?
Provide a short and direct response. 1. What is the ratio of the Rating (1=low 6=high) of Nigeria in 2005 to that in 2012?
Ensure brevity in your answer.  1. What is the ratio of the Rating (1=low 6=high) in East Asia (all income levels) in 2006 to that in 2007?
Provide a short and direct response. 1.03. What is the ratio of the Rating (1=low 6=high) of Low income in 2006 to that in 2007?
Give a very brief answer. 0.98. What is the ratio of the Rating (1=low 6=high) in Nigeria in 2006 to that in 2007?
Provide a succinct answer. 1. What is the ratio of the Rating (1=low 6=high) in Guyana in 2006 to that in 2008?
Offer a very short reply. 1. What is the ratio of the Rating (1=low 6=high) in East Asia (all income levels) in 2006 to that in 2009?
Offer a terse response. 0.97. What is the ratio of the Rating (1=low 6=high) of Low income in 2006 to that in 2009?
Ensure brevity in your answer.  0.97. What is the ratio of the Rating (1=low 6=high) in Guyana in 2006 to that in 2009?
Offer a terse response. 1. What is the ratio of the Rating (1=low 6=high) of East Asia (all income levels) in 2006 to that in 2010?
Provide a succinct answer. 0.93. What is the ratio of the Rating (1=low 6=high) in Low income in 2006 to that in 2010?
Your answer should be very brief. 0.97. What is the ratio of the Rating (1=low 6=high) of Guyana in 2006 to that in 2010?
Your response must be concise. 1. What is the ratio of the Rating (1=low 6=high) in East Asia (all income levels) in 2006 to that in 2011?
Give a very brief answer. 0.95. What is the ratio of the Rating (1=low 6=high) of Low income in 2006 to that in 2011?
Your answer should be compact. 0.95. What is the ratio of the Rating (1=low 6=high) in Guyana in 2006 to that in 2011?
Your answer should be compact. 1. What is the ratio of the Rating (1=low 6=high) of Nigeria in 2006 to that in 2011?
Keep it short and to the point. 1. What is the ratio of the Rating (1=low 6=high) of East Asia (all income levels) in 2006 to that in 2012?
Offer a very short reply. 0.97. What is the ratio of the Rating (1=low 6=high) in Low income in 2006 to that in 2012?
Your response must be concise. 0.97. What is the ratio of the Rating (1=low 6=high) in East Asia (all income levels) in 2007 to that in 2008?
Your answer should be very brief. 0.99. What is the ratio of the Rating (1=low 6=high) of Guyana in 2007 to that in 2008?
Provide a succinct answer. 1. What is the ratio of the Rating (1=low 6=high) of Nigeria in 2007 to that in 2008?
Your response must be concise. 1. What is the ratio of the Rating (1=low 6=high) in East Asia (all income levels) in 2007 to that in 2009?
Ensure brevity in your answer.  0.93. What is the ratio of the Rating (1=low 6=high) of Low income in 2007 to that in 2009?
Your answer should be very brief. 0.99. What is the ratio of the Rating (1=low 6=high) in Guyana in 2007 to that in 2009?
Provide a short and direct response. 1. What is the ratio of the Rating (1=low 6=high) of East Asia (all income levels) in 2007 to that in 2010?
Ensure brevity in your answer.  0.9. What is the ratio of the Rating (1=low 6=high) of Low income in 2007 to that in 2010?
Your answer should be very brief. 0.99. What is the ratio of the Rating (1=low 6=high) in Guyana in 2007 to that in 2010?
Offer a terse response. 1. What is the ratio of the Rating (1=low 6=high) in East Asia (all income levels) in 2007 to that in 2011?
Offer a terse response. 0.92. What is the ratio of the Rating (1=low 6=high) in Low income in 2007 to that in 2011?
Provide a short and direct response. 0.97. What is the ratio of the Rating (1=low 6=high) in East Asia (all income levels) in 2007 to that in 2012?
Ensure brevity in your answer.  0.94. What is the ratio of the Rating (1=low 6=high) of Low income in 2007 to that in 2012?
Ensure brevity in your answer.  0.98. What is the ratio of the Rating (1=low 6=high) of Guyana in 2007 to that in 2012?
Provide a short and direct response. 1. What is the ratio of the Rating (1=low 6=high) of Nigeria in 2007 to that in 2012?
Your answer should be compact. 1. What is the ratio of the Rating (1=low 6=high) in East Asia (all income levels) in 2008 to that in 2009?
Provide a succinct answer. 0.95. What is the ratio of the Rating (1=low 6=high) of Guyana in 2008 to that in 2009?
Ensure brevity in your answer.  1. What is the ratio of the Rating (1=low 6=high) of Nigeria in 2008 to that in 2009?
Your response must be concise. 1. What is the ratio of the Rating (1=low 6=high) of East Asia (all income levels) in 2008 to that in 2010?
Provide a short and direct response. 0.91. What is the ratio of the Rating (1=low 6=high) in Guyana in 2008 to that in 2010?
Your answer should be very brief. 1. What is the ratio of the Rating (1=low 6=high) in Nigeria in 2008 to that in 2010?
Provide a succinct answer. 1. What is the ratio of the Rating (1=low 6=high) of East Asia (all income levels) in 2008 to that in 2011?
Make the answer very short. 0.93. What is the ratio of the Rating (1=low 6=high) in Low income in 2008 to that in 2011?
Offer a very short reply. 0.98. What is the ratio of the Rating (1=low 6=high) of East Asia (all income levels) in 2008 to that in 2012?
Provide a short and direct response. 0.95. What is the ratio of the Rating (1=low 6=high) of Low income in 2008 to that in 2012?
Provide a succinct answer. 0.99. What is the ratio of the Rating (1=low 6=high) of Guyana in 2008 to that in 2012?
Offer a very short reply. 1. What is the ratio of the Rating (1=low 6=high) of Nigeria in 2008 to that in 2012?
Offer a terse response. 1. What is the ratio of the Rating (1=low 6=high) in East Asia (all income levels) in 2009 to that in 2010?
Your answer should be very brief. 0.96. What is the ratio of the Rating (1=low 6=high) in Nigeria in 2009 to that in 2010?
Give a very brief answer. 1. What is the ratio of the Rating (1=low 6=high) in Low income in 2009 to that in 2011?
Offer a very short reply. 0.98. What is the ratio of the Rating (1=low 6=high) of Guyana in 2009 to that in 2011?
Offer a terse response. 1. What is the ratio of the Rating (1=low 6=high) in Guyana in 2009 to that in 2012?
Offer a very short reply. 1. What is the ratio of the Rating (1=low 6=high) in East Asia (all income levels) in 2010 to that in 2011?
Provide a short and direct response. 1.02. What is the ratio of the Rating (1=low 6=high) in Low income in 2010 to that in 2011?
Offer a very short reply. 0.98. What is the ratio of the Rating (1=low 6=high) in Nigeria in 2010 to that in 2011?
Ensure brevity in your answer.  1. What is the ratio of the Rating (1=low 6=high) in East Asia (all income levels) in 2010 to that in 2012?
Provide a succinct answer. 1.04. What is the ratio of the Rating (1=low 6=high) of Low income in 2010 to that in 2012?
Offer a terse response. 1. What is the ratio of the Rating (1=low 6=high) in East Asia (all income levels) in 2011 to that in 2012?
Offer a very short reply. 1.02. What is the ratio of the Rating (1=low 6=high) in Low income in 2011 to that in 2012?
Offer a terse response. 1.01. What is the ratio of the Rating (1=low 6=high) of Guyana in 2011 to that in 2012?
Provide a succinct answer. 1. What is the difference between the highest and the second highest Rating (1=low 6=high) in East Asia (all income levels)?
Provide a short and direct response. 0.08. What is the difference between the highest and the second highest Rating (1=low 6=high) of Low income?
Provide a short and direct response. 0.04. What is the difference between the highest and the second highest Rating (1=low 6=high) of Nigeria?
Your response must be concise. 0. What is the difference between the highest and the lowest Rating (1=low 6=high) in East Asia (all income levels)?
Give a very brief answer. 0.36. What is the difference between the highest and the lowest Rating (1=low 6=high) in Low income?
Your answer should be very brief. 0.16. What is the difference between the highest and the lowest Rating (1=low 6=high) of Guyana?
Make the answer very short. 0. 